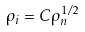<formula> <loc_0><loc_0><loc_500><loc_500>\rho _ { i } = C \rho _ { n } ^ { 1 / 2 }</formula> 